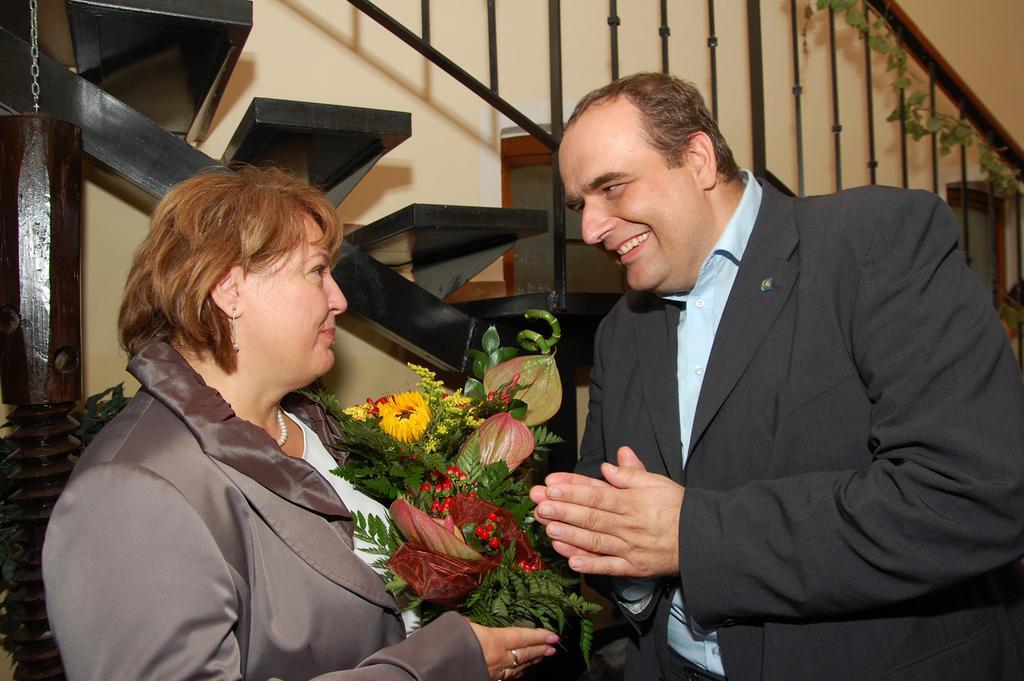Could you give a brief overview of what you see in this image? There are two persons and smiling and this person holding bouquet. Background we can see wall and steps. 